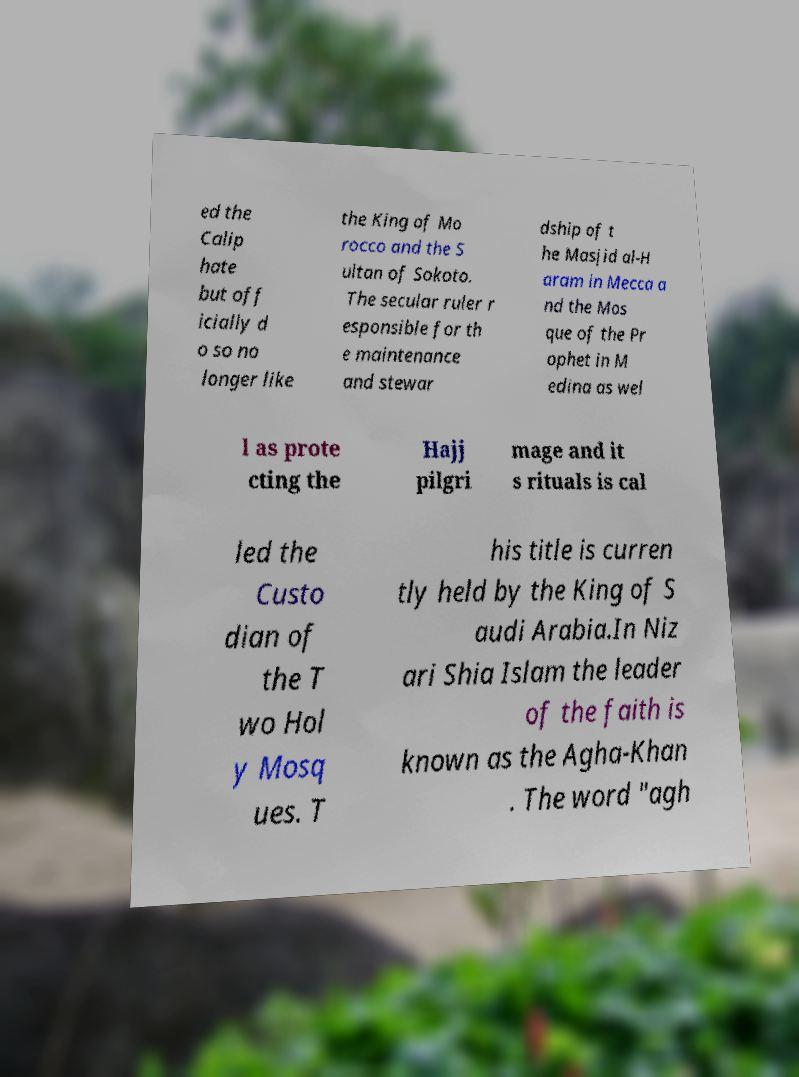I need the written content from this picture converted into text. Can you do that? ed the Calip hate but off icially d o so no longer like the King of Mo rocco and the S ultan of Sokoto. The secular ruler r esponsible for th e maintenance and stewar dship of t he Masjid al-H aram in Mecca a nd the Mos que of the Pr ophet in M edina as wel l as prote cting the Hajj pilgri mage and it s rituals is cal led the Custo dian of the T wo Hol y Mosq ues. T his title is curren tly held by the King of S audi Arabia.In Niz ari Shia Islam the leader of the faith is known as the Agha-Khan . The word "agh 